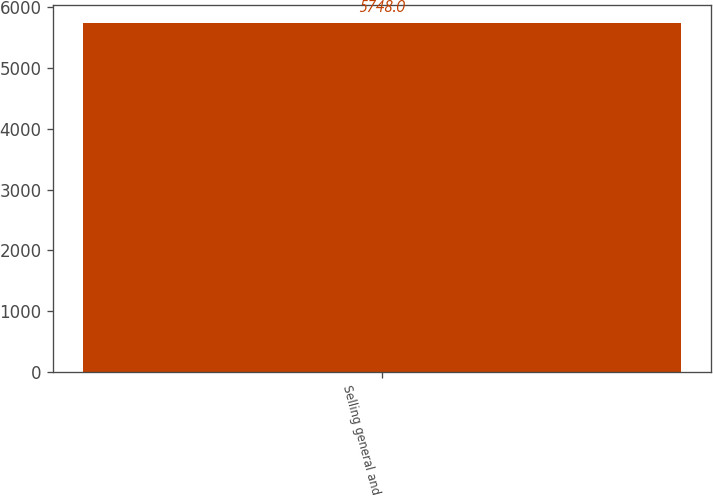Convert chart. <chart><loc_0><loc_0><loc_500><loc_500><bar_chart><fcel>Selling general and<nl><fcel>5748<nl></chart> 